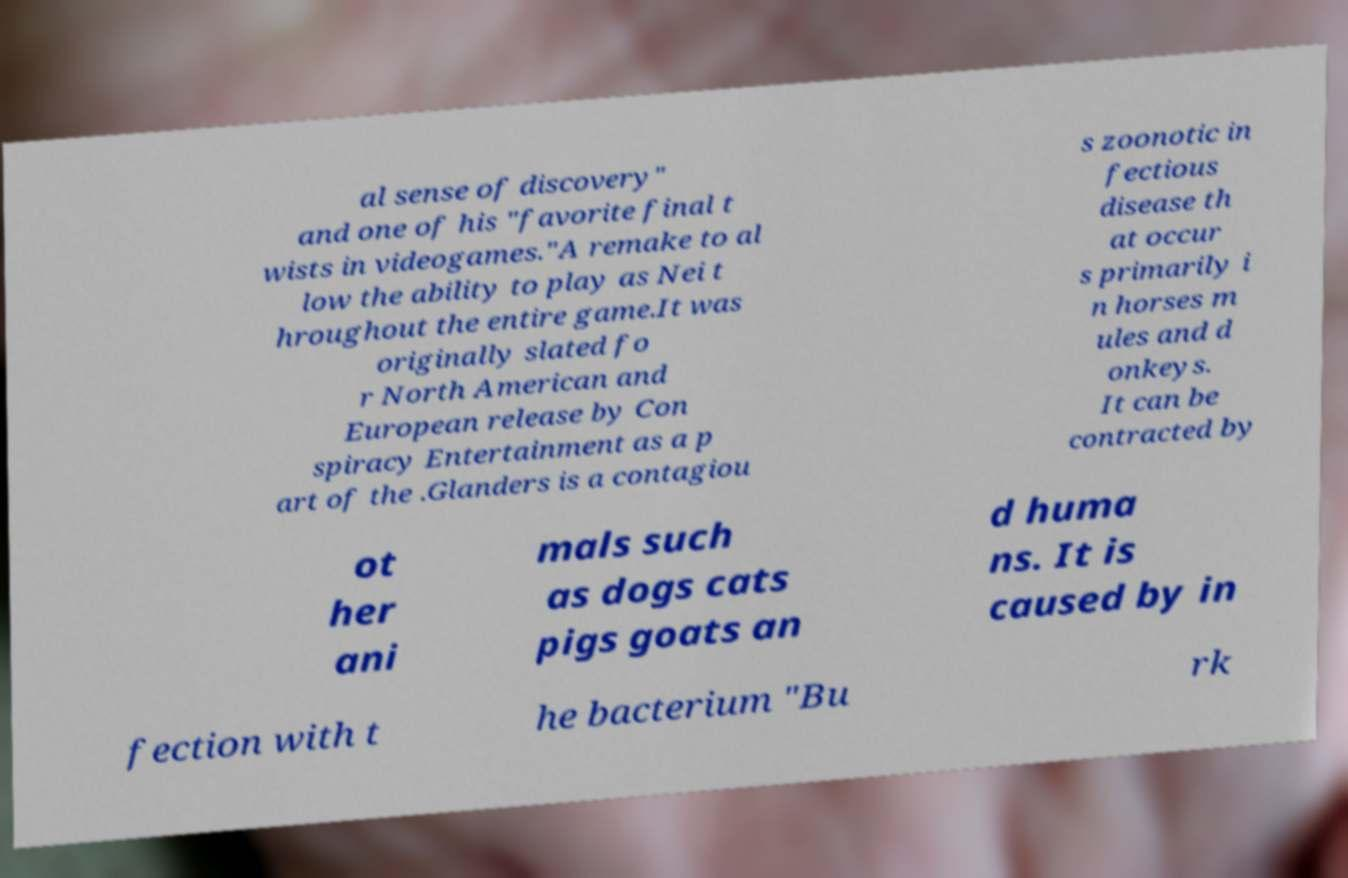I need the written content from this picture converted into text. Can you do that? al sense of discovery" and one of his "favorite final t wists in videogames."A remake to al low the ability to play as Nei t hroughout the entire game.It was originally slated fo r North American and European release by Con spiracy Entertainment as a p art of the .Glanders is a contagiou s zoonotic in fectious disease th at occur s primarily i n horses m ules and d onkeys. It can be contracted by ot her ani mals such as dogs cats pigs goats an d huma ns. It is caused by in fection with t he bacterium "Bu rk 